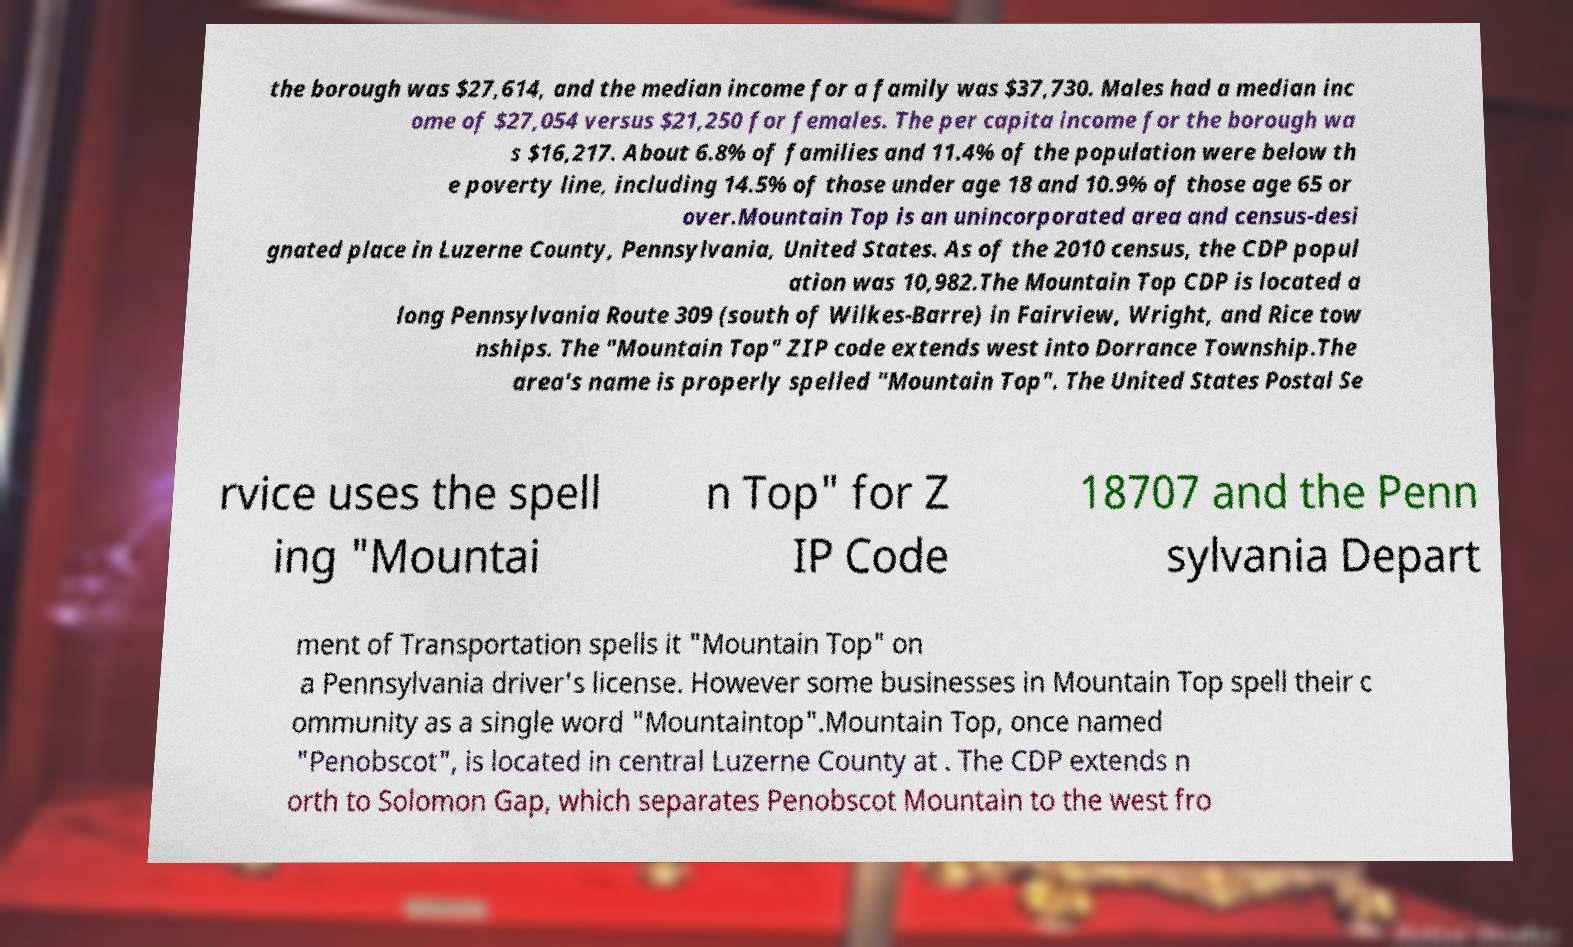Could you assist in decoding the text presented in this image and type it out clearly? the borough was $27,614, and the median income for a family was $37,730. Males had a median inc ome of $27,054 versus $21,250 for females. The per capita income for the borough wa s $16,217. About 6.8% of families and 11.4% of the population were below th e poverty line, including 14.5% of those under age 18 and 10.9% of those age 65 or over.Mountain Top is an unincorporated area and census-desi gnated place in Luzerne County, Pennsylvania, United States. As of the 2010 census, the CDP popul ation was 10,982.The Mountain Top CDP is located a long Pennsylvania Route 309 (south of Wilkes-Barre) in Fairview, Wright, and Rice tow nships. The "Mountain Top" ZIP code extends west into Dorrance Township.The area's name is properly spelled "Mountain Top". The United States Postal Se rvice uses the spell ing "Mountai n Top" for Z IP Code 18707 and the Penn sylvania Depart ment of Transportation spells it "Mountain Top" on a Pennsylvania driver's license. However some businesses in Mountain Top spell their c ommunity as a single word "Mountaintop".Mountain Top, once named "Penobscot", is located in central Luzerne County at . The CDP extends n orth to Solomon Gap, which separates Penobscot Mountain to the west fro 